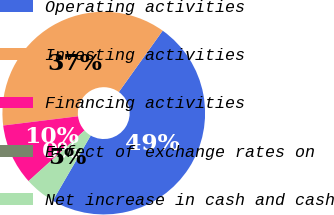Convert chart to OTSL. <chart><loc_0><loc_0><loc_500><loc_500><pie_chart><fcel>Operating activities<fcel>Investing activities<fcel>Financing activities<fcel>Effect of exchange rates on<fcel>Net increase in cash and cash<nl><fcel>48.51%<fcel>36.83%<fcel>9.73%<fcel>0.04%<fcel>4.89%<nl></chart> 